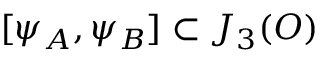<formula> <loc_0><loc_0><loc_500><loc_500>[ \psi _ { A } , \psi _ { B } ] \subset J _ { 3 } ( O )</formula> 